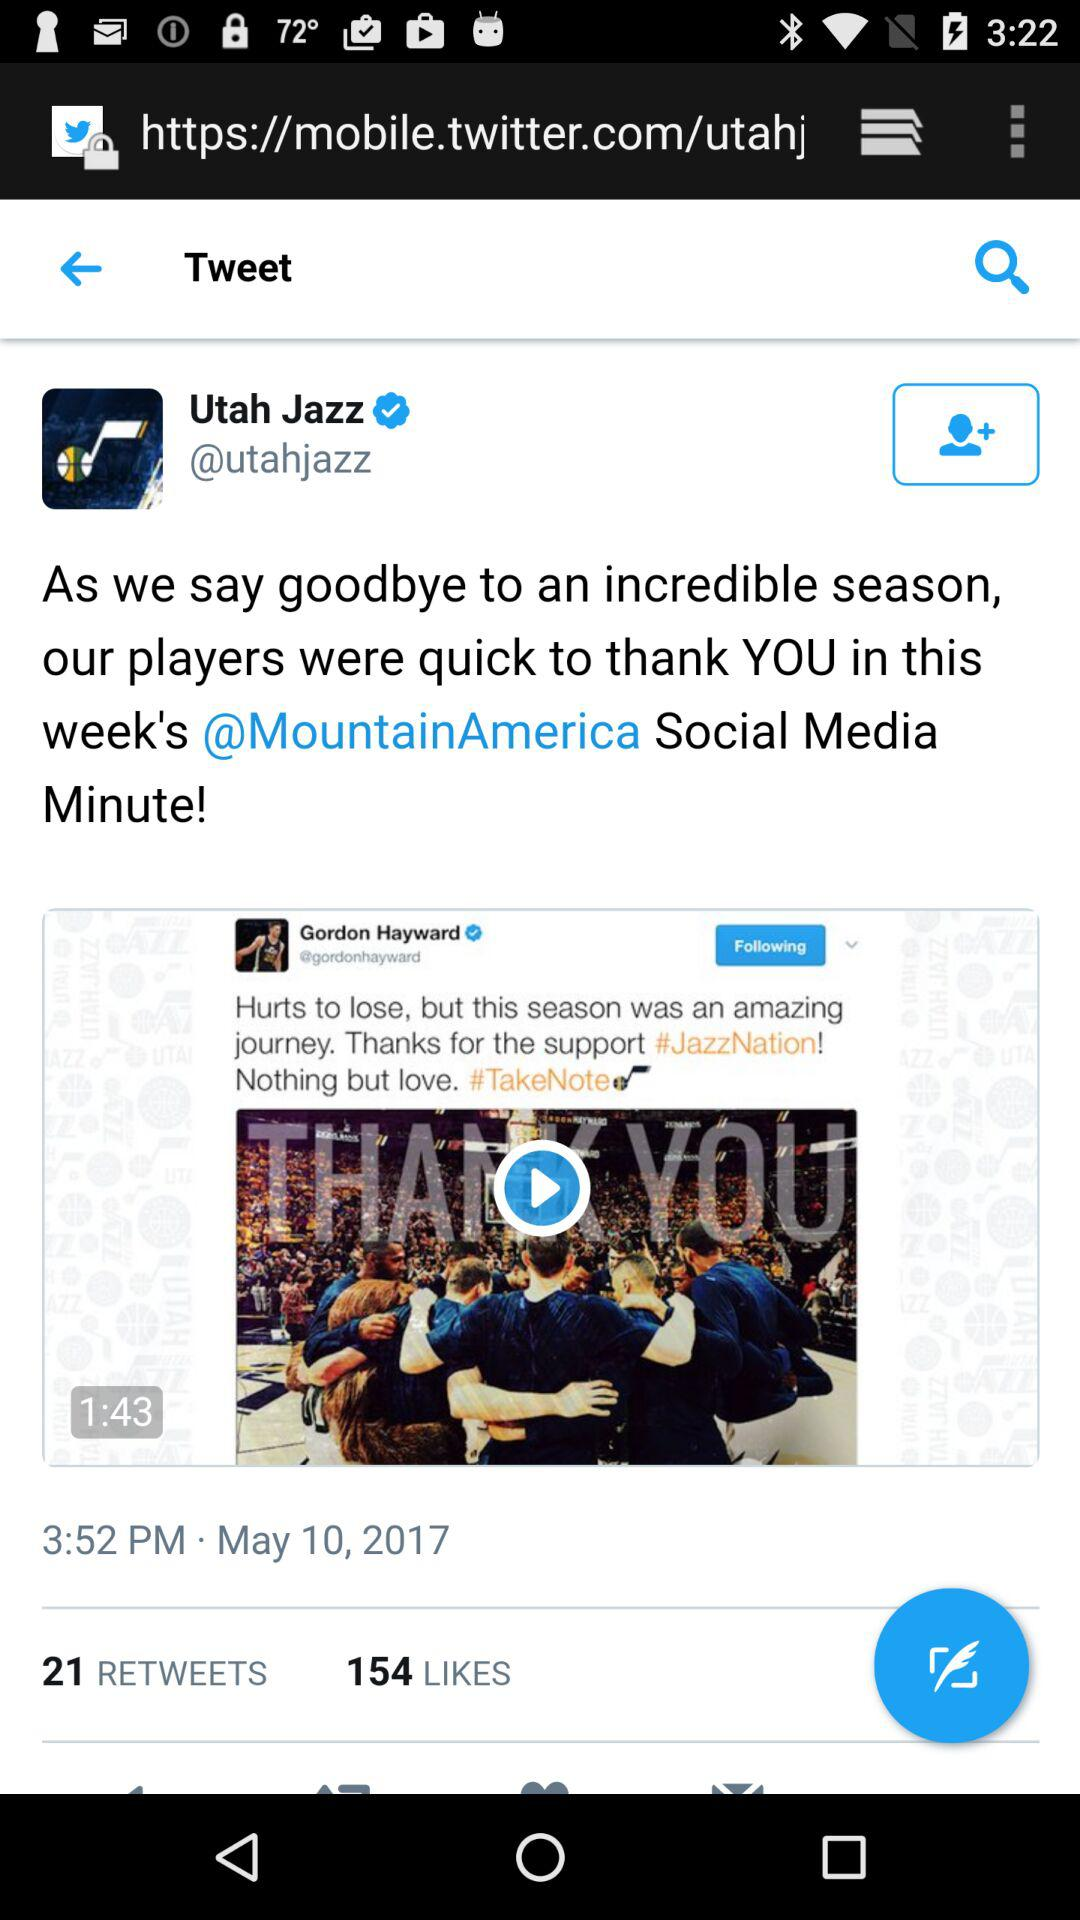What is the duration of the video posted by the Utah Jazz? The duration of the video is 1:43. 